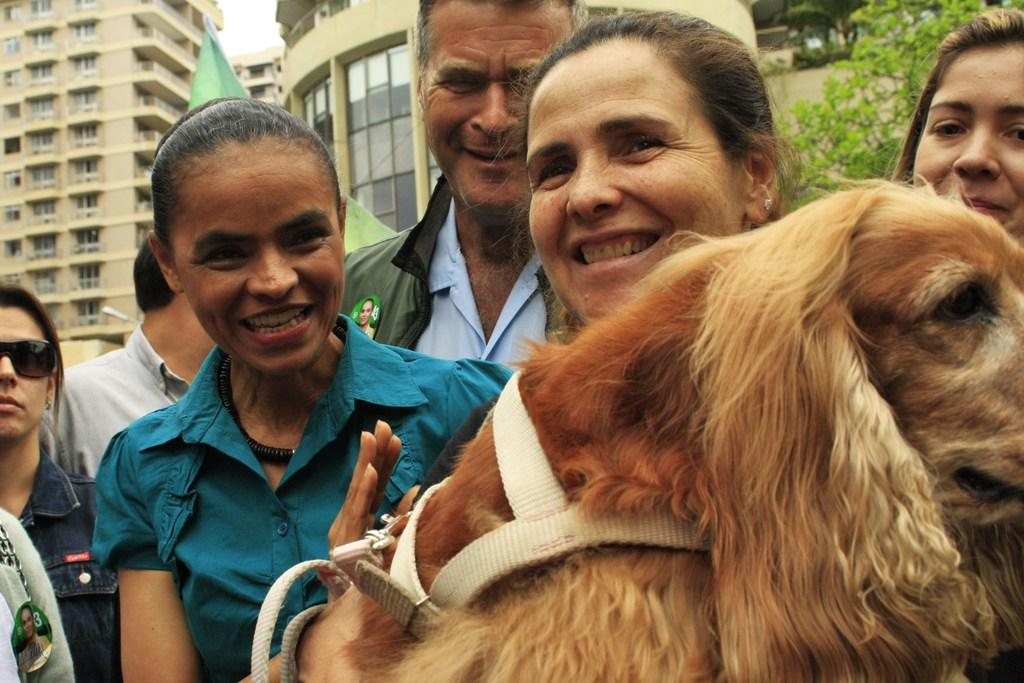How many people are present in the image? There are multiple people in the image. What is the woman in the image holding? The woman is holding a dog. Can you describe the expressions of the people in the image? Some people in the image are smiling. What can be seen in the background of the image? There are trees and buildings in the background of the image. What type of advertisement can be seen in space in the image? There is no advertisement in space present in the image. 